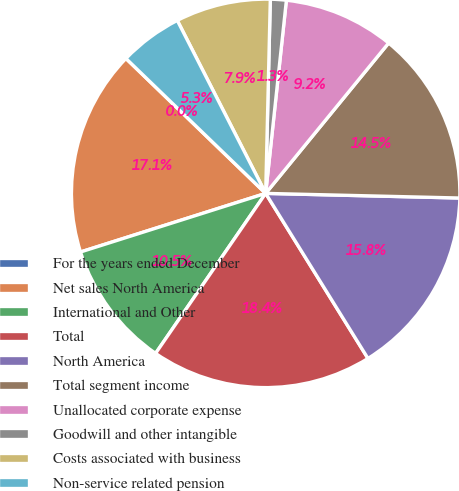Convert chart to OTSL. <chart><loc_0><loc_0><loc_500><loc_500><pie_chart><fcel>For the years ended December<fcel>Net sales North America<fcel>International and Other<fcel>Total<fcel>North America<fcel>Total segment income<fcel>Unallocated corporate expense<fcel>Goodwill and other intangible<fcel>Costs associated with business<fcel>Non-service related pension<nl><fcel>0.0%<fcel>17.1%<fcel>10.53%<fcel>18.42%<fcel>15.79%<fcel>14.47%<fcel>9.21%<fcel>1.32%<fcel>7.9%<fcel>5.26%<nl></chart> 